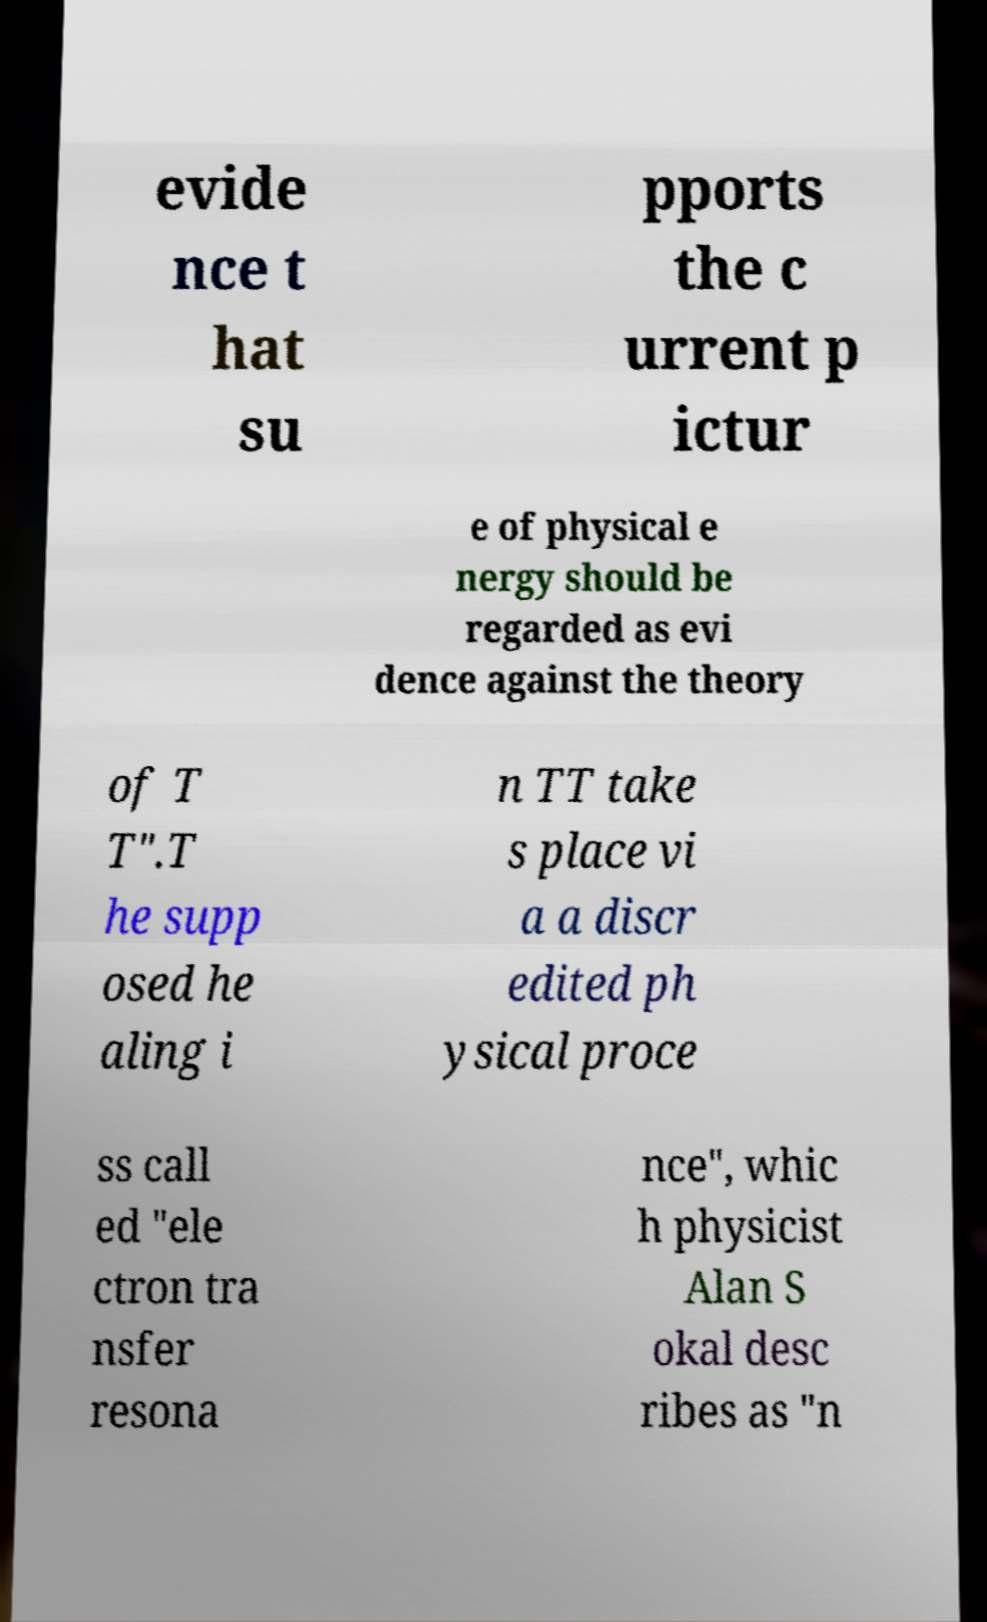I need the written content from this picture converted into text. Can you do that? evide nce t hat su pports the c urrent p ictur e of physical e nergy should be regarded as evi dence against the theory of T T".T he supp osed he aling i n TT take s place vi a a discr edited ph ysical proce ss call ed "ele ctron tra nsfer resona nce", whic h physicist Alan S okal desc ribes as "n 